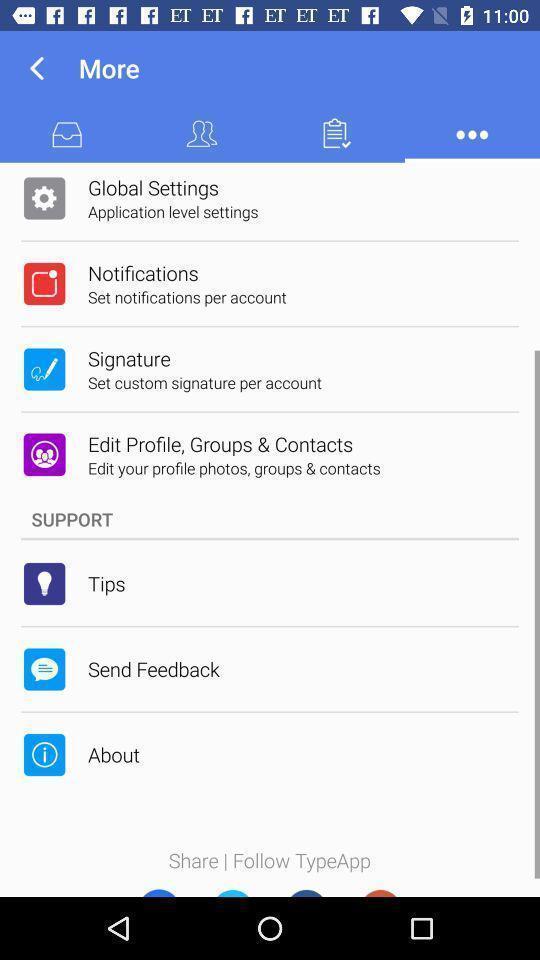Describe the content in this image. Screen displaying the page for more information. 